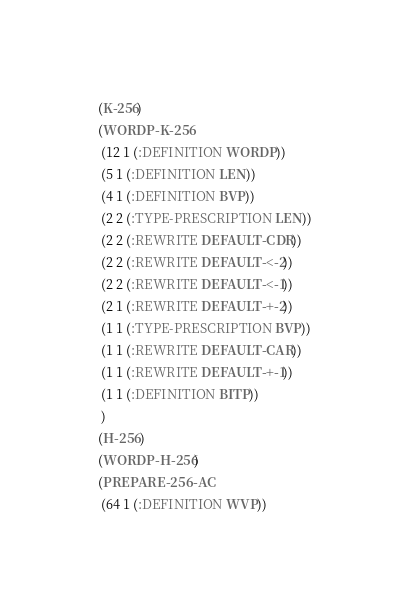<code> <loc_0><loc_0><loc_500><loc_500><_Lisp_>(K-256)
(WORDP-K-256
 (12 1 (:DEFINITION WORDP))
 (5 1 (:DEFINITION LEN))
 (4 1 (:DEFINITION BVP))
 (2 2 (:TYPE-PRESCRIPTION LEN))
 (2 2 (:REWRITE DEFAULT-CDR))
 (2 2 (:REWRITE DEFAULT-<-2))
 (2 2 (:REWRITE DEFAULT-<-1))
 (2 1 (:REWRITE DEFAULT-+-2))
 (1 1 (:TYPE-PRESCRIPTION BVP))
 (1 1 (:REWRITE DEFAULT-CAR))
 (1 1 (:REWRITE DEFAULT-+-1))
 (1 1 (:DEFINITION BITP))
 )
(H-256)
(WORDP-H-256)
(PREPARE-256-AC
 (64 1 (:DEFINITION WVP))</code> 